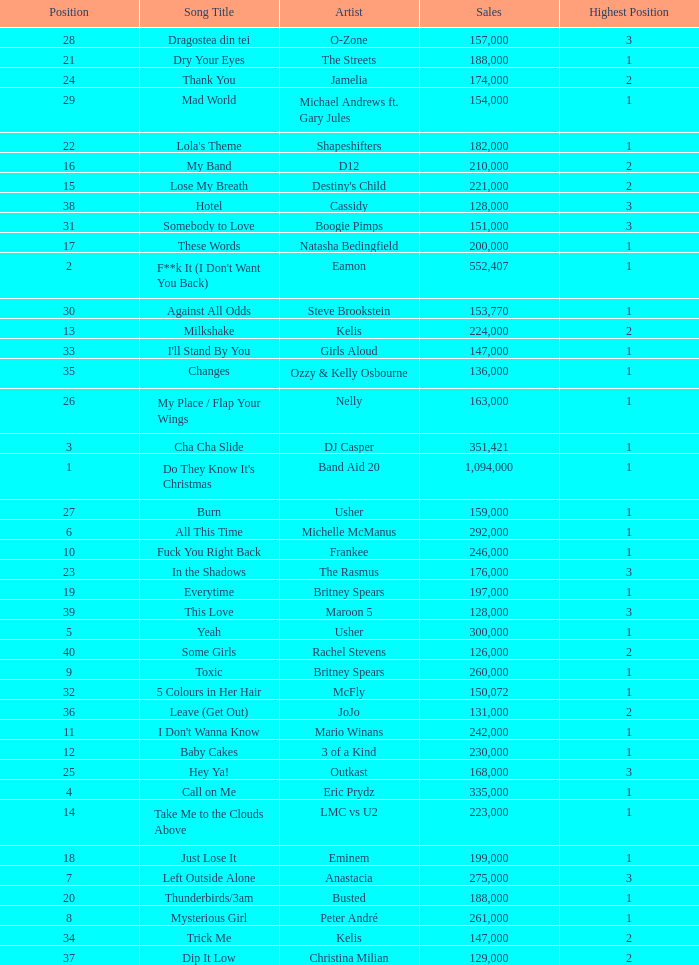What is the most sales by a song with a position higher than 3? None. 